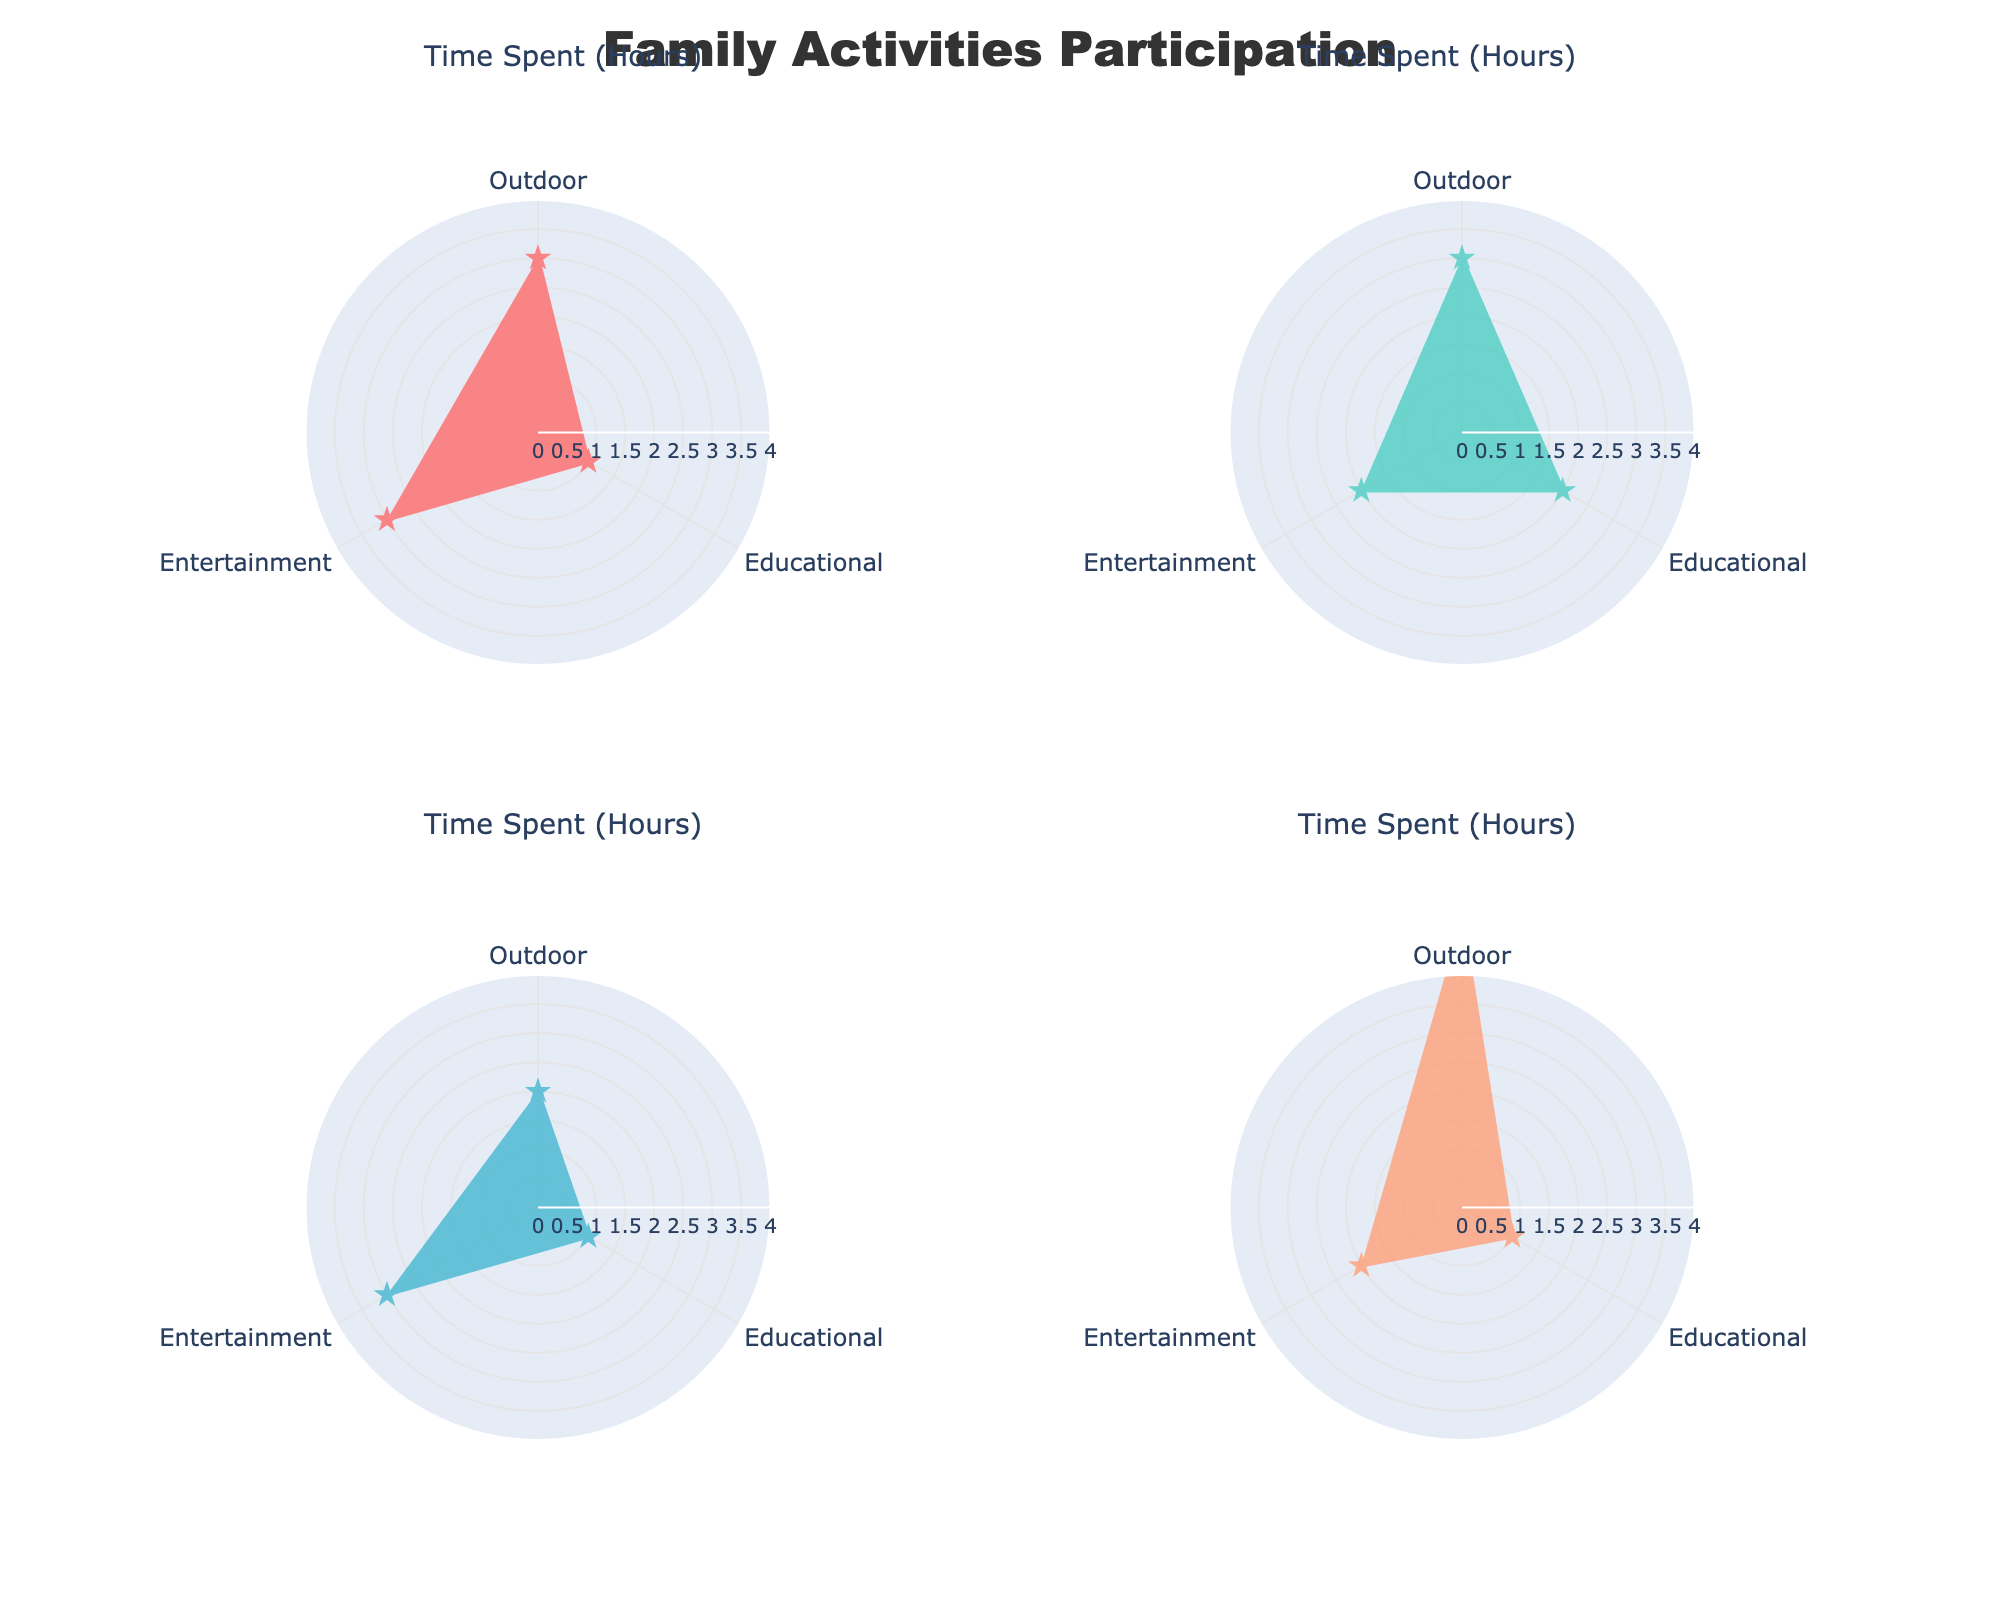Which family member spends the most time on Outdoor activities? To determine which family member spends the most time on Outdoor activities, one would compare the sum of hours spent in Outdoor activities for each family member. The chart for each family member shows the hours spent on different activities. Hence, by comparing the corresponding segments, the Parent and Child (with Whole Family spending time on outdoor activities) spend a total of 5 hours each.
Answer: Parent and Child Which activity type does the child spend the most hours on during the weekends? Looking at the polar chart for the Child, observe the length of the segments. The activity with the longest segment indicates the maximum hours spent. The Entertainment segment with 2 hours of Video Games has the longest length.
Answer: Entertainment How many hours in total does the sibling spend on Educational activities? In the sibling's polar chart, sum the hours for the Educational activities. Identify and add the segments corresponding to Library Visit (1 hour). Thus, the total is 1 hour.
Answer: 1 Compare the total hours spent on Entertainment activities by the Parent and the Sibling. Who spends more hours, and by how much? Calculate the total hours spent on Entertainment activities for the Parent and Sibling from their respective polar charts. The Parent spends 3 hours on Movie Watching. The Sibling spends 3 hours on Board Games. The difference is 3 - 3 = 0 hours.
Answer: Equal, 0 hours What is the most common activity type among all family members during the weekends? Observe the overall distribution of activities in all subplots to determine the most common activity type. Adding up the segments of each subplot, Outdoor activities (Hiking, Cycling, Picnic in Park, Family Sports) sum up to 13 hours. This is the highest among the given activity types.
Answer: Outdoor How much more time does the Whole Family spend on Outdoor activities compared to Entertainment? In the Whole Family's polar chart, compare the length of segments for Outdoor and Entertainment activities. For Outdoor, sum the hours (Picnic in Park: 3, Family Sports: 2 totaling 5) and for Entertainment (Amusement Park visit: 2). The difference is 5 - 2 = 3 hours.
Answer: 3 hours Which activity category does the Whole Family spend the least amount of time on? In the Whole Family's polar chart, identify the segment with the smallest length. The shortest segment corresponds to the Science Exhibition (Educational: 1 hour).
Answer: Educational Which family member spends the most hours on Educational activities? Compare the lengths of the Educational activity segments across all family members' subplots. The Child spends the most time with 2 hours on Music Lessons.
Answer: Child What is the overall proportion of time spent on Entertainment activities by all family members together? Sum the total hours spent on Entertainment activities for all family members: Parent (3), Child (2), Sibling (3), and Whole Family (2). The total is 3+2+3+2=10 hours. Sum the total hours spent on all activities (26 hours). The proportion is 10/26≈0.385 or approximately 38.5%.
Answer: 38.5% 